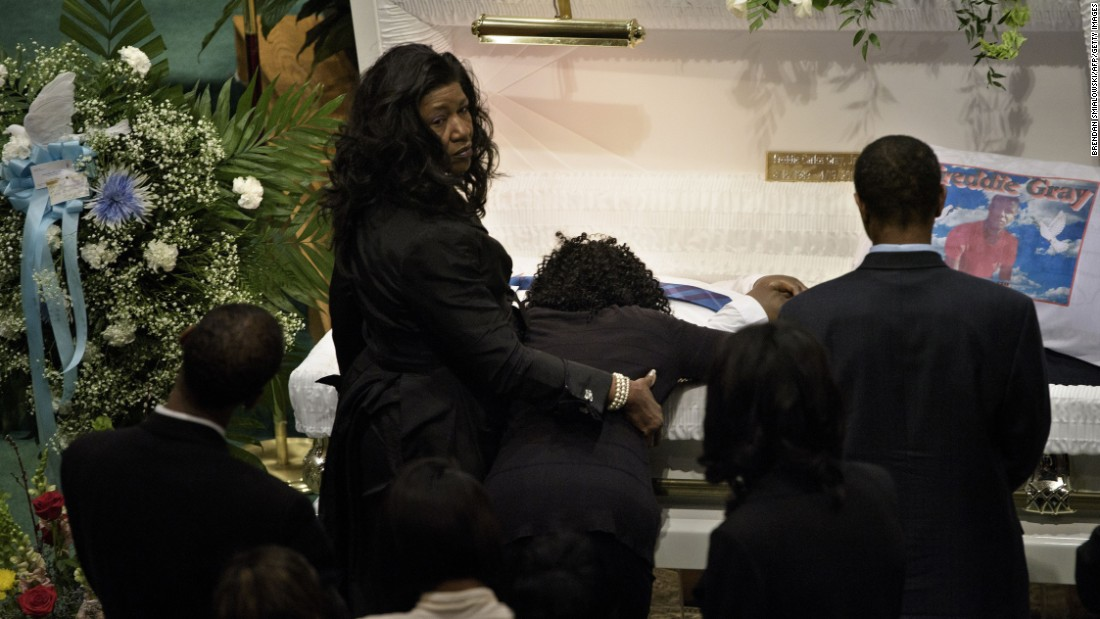How does the body language of the individuals around the casket reflect their emotional state? The body language of the individuals around the casket indicates profound grief and sorrow. The person leaning over the casket has their head down, which could signify deep sadness or a final moment of closeness with the deceased. The woman standing with her hand on the shoulder of the grieving individual is providing support, her slightly furrowed brow and direct gaze towards the camera conveying a mix of sadness and strength. The other attendees have their heads bowed and seem to be in a state of reflection or prayer, which is common in such emotional and solemn circumstances. Overall, the posture and expressions of the people in the image are indicative of a community in mourning. 